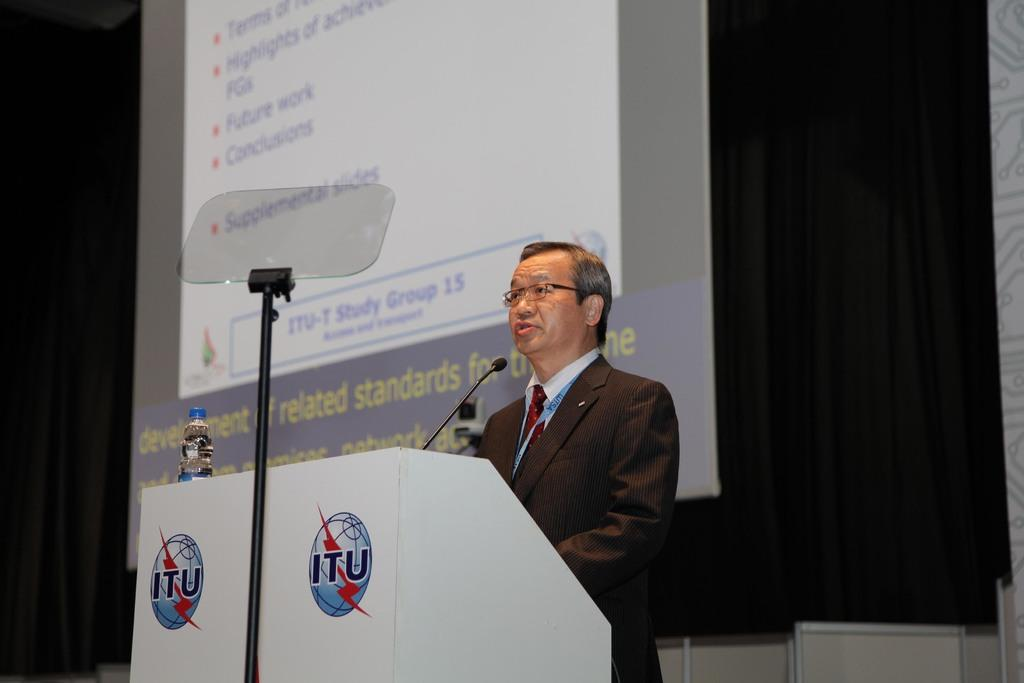Who is the main subject in the image? There is a man in the middle of the image. What is the man wearing? The man is wearing a suit, shirt, and tie. What is in front of the man? There is a podium in front of the man. What is on the podium? A microphone and a bottle are present on the podium. What can be seen in the background of the image? There is a screen and a poster in the background of the image. Can you tell me how many flowers are on the basketball court in the image? There are no flowers or basketball courts present in the image. 